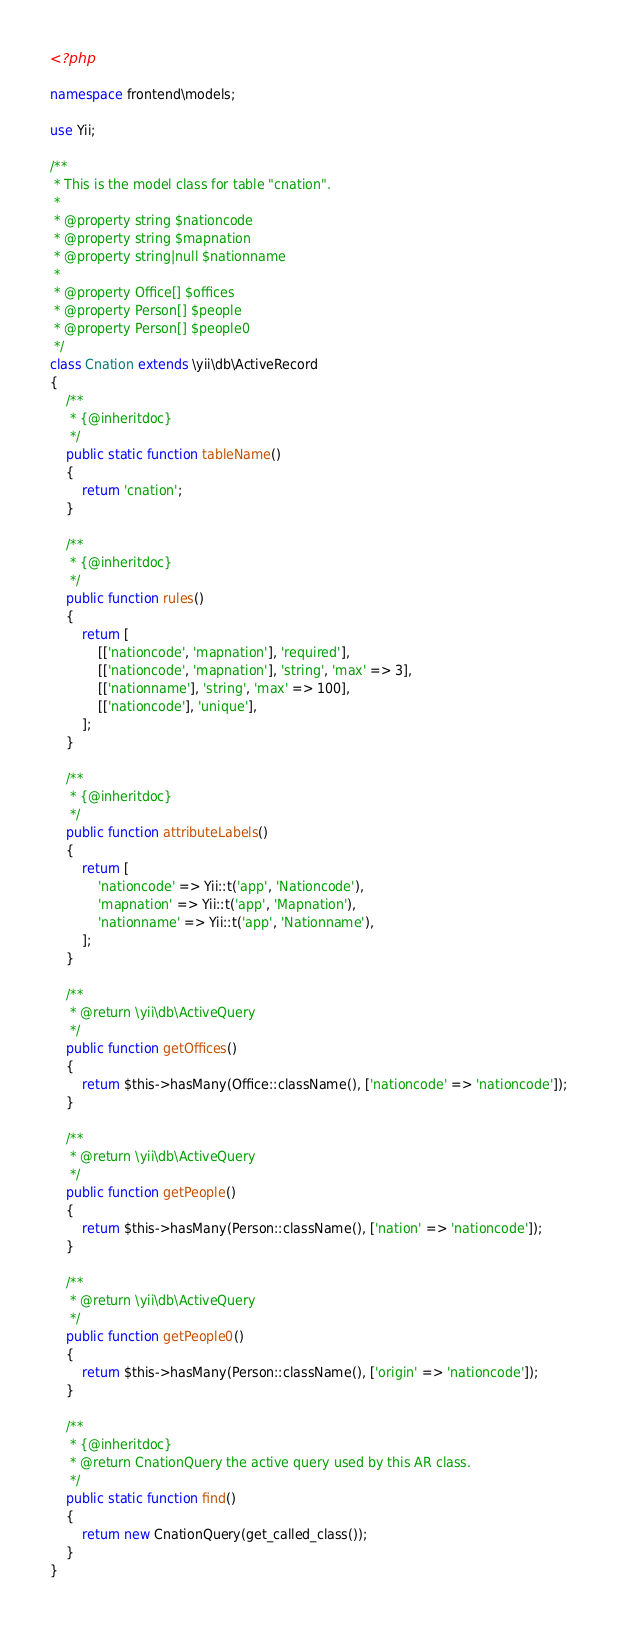Convert code to text. <code><loc_0><loc_0><loc_500><loc_500><_PHP_><?php

namespace frontend\models;

use Yii;

/**
 * This is the model class for table "cnation".
 *
 * @property string $nationcode
 * @property string $mapnation
 * @property string|null $nationname
 *
 * @property Office[] $offices
 * @property Person[] $people
 * @property Person[] $people0
 */
class Cnation extends \yii\db\ActiveRecord
{
    /**
     * {@inheritdoc}
     */
    public static function tableName()
    {
        return 'cnation';
    }

    /**
     * {@inheritdoc}
     */
    public function rules()
    {
        return [
            [['nationcode', 'mapnation'], 'required'],
            [['nationcode', 'mapnation'], 'string', 'max' => 3],
            [['nationname'], 'string', 'max' => 100],
            [['nationcode'], 'unique'],
        ];
    }

    /**
     * {@inheritdoc}
     */
    public function attributeLabels()
    {
        return [
            'nationcode' => Yii::t('app', 'Nationcode'),
            'mapnation' => Yii::t('app', 'Mapnation'),
            'nationname' => Yii::t('app', 'Nationname'),
        ];
    }

    /**
     * @return \yii\db\ActiveQuery
     */
    public function getOffices()
    {
        return $this->hasMany(Office::className(), ['nationcode' => 'nationcode']);
    }

    /**
     * @return \yii\db\ActiveQuery
     */
    public function getPeople()
    {
        return $this->hasMany(Person::className(), ['nation' => 'nationcode']);
    }

    /**
     * @return \yii\db\ActiveQuery
     */
    public function getPeople0()
    {
        return $this->hasMany(Person::className(), ['origin' => 'nationcode']);
    }

    /**
     * {@inheritdoc}
     * @return CnationQuery the active query used by this AR class.
     */
    public static function find()
    {
        return new CnationQuery(get_called_class());
    }
}
</code> 